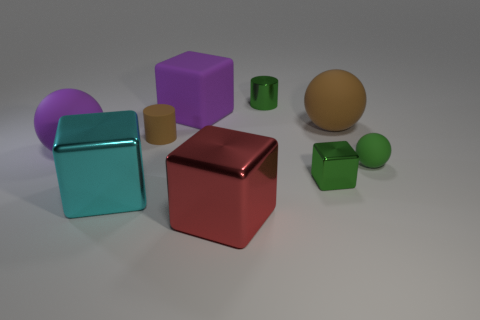What is the shape of the matte thing that is left of the tiny cylinder that is on the left side of the tiny green thing that is on the left side of the tiny block? sphere 